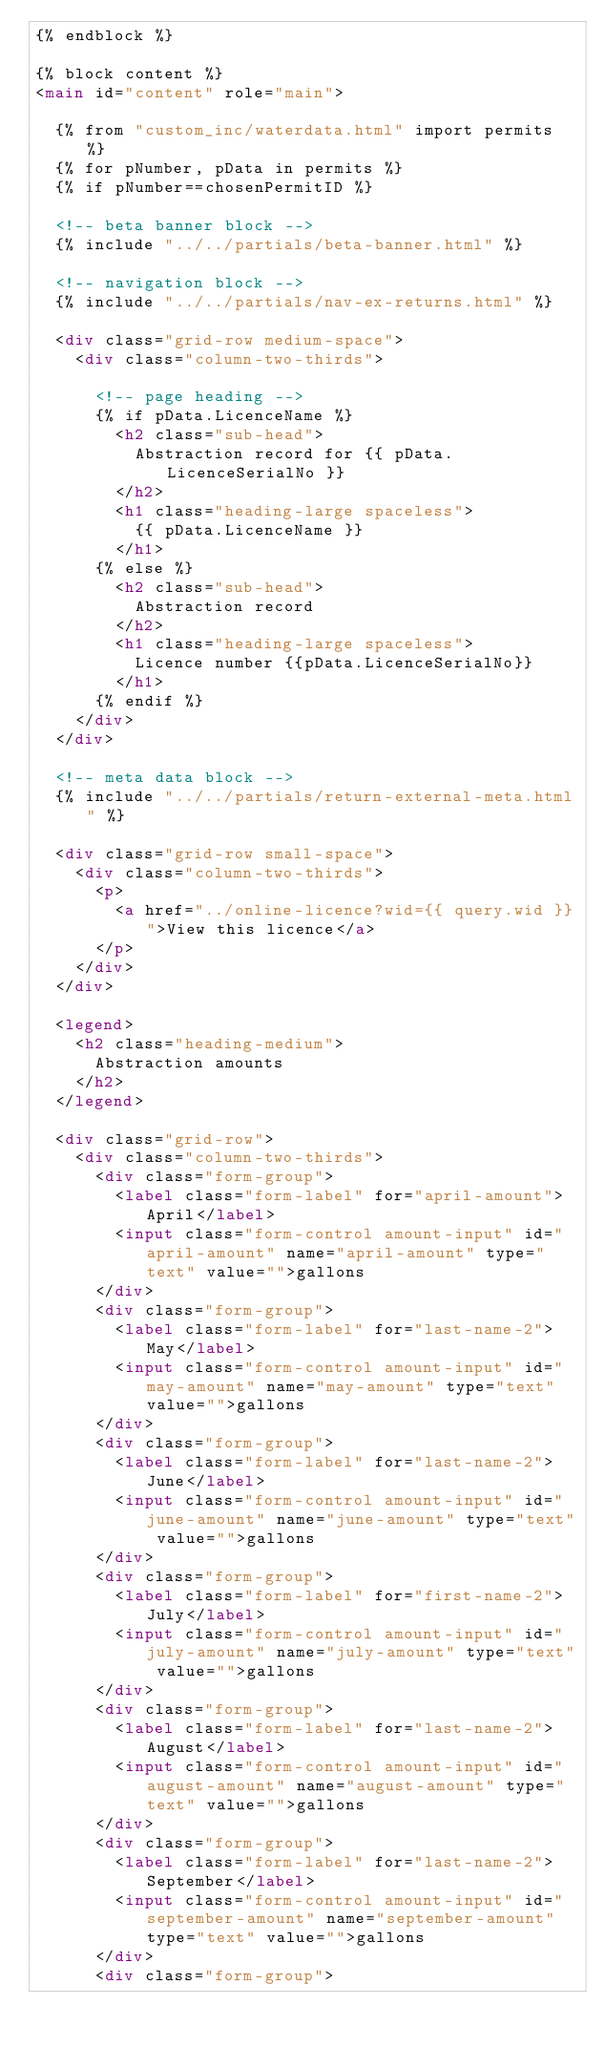Convert code to text. <code><loc_0><loc_0><loc_500><loc_500><_HTML_>{% endblock %}

{% block content %}
<main id="content" role="main">

  {% from "custom_inc/waterdata.html" import permits %}
  {% for pNumber, pData in permits %}
  {% if pNumber==chosenPermitID %}

  <!-- beta banner block -->
  {% include "../../partials/beta-banner.html" %}

  <!-- navigation block -->
  {% include "../../partials/nav-ex-returns.html" %}

  <div class="grid-row medium-space">
    <div class="column-two-thirds">

      <!-- page heading -->
      {% if pData.LicenceName %}
        <h2 class="sub-head">
          Abstraction record for {{ pData.LicenceSerialNo }}
        </h2>
        <h1 class="heading-large spaceless">
          {{ pData.LicenceName }}
        </h1>
      {% else %}
        <h2 class="sub-head">
          Abstraction record
        </h2>
        <h1 class="heading-large spaceless">
          Licence number {{pData.LicenceSerialNo}}
        </h1>
      {% endif %}
    </div>
  </div>

  <!-- meta data block -->
  {% include "../../partials/return-external-meta.html" %}

  <div class="grid-row small-space">
    <div class="column-two-thirds">
      <p>
        <a href="../online-licence?wid={{ query.wid }}">View this licence</a>
      </p>
    </div>
  </div>

  <legend>
    <h2 class="heading-medium">
      Abstraction amounts
    </h2>
  </legend>

  <div class="grid-row">
    <div class="column-two-thirds">
      <div class="form-group">
        <label class="form-label" for="april-amount">April</label>
        <input class="form-control amount-input" id="april-amount" name="april-amount" type="text" value="">gallons
      </div>
      <div class="form-group">
        <label class="form-label" for="last-name-2">May</label>
        <input class="form-control amount-input" id="may-amount" name="may-amount" type="text" value="">gallons
      </div>
      <div class="form-group">
        <label class="form-label" for="last-name-2">June</label>
        <input class="form-control amount-input" id="june-amount" name="june-amount" type="text" value="">gallons
      </div>
      <div class="form-group">
        <label class="form-label" for="first-name-2">July</label>
        <input class="form-control amount-input" id="july-amount" name="july-amount" type="text" value="">gallons
      </div>
      <div class="form-group">
        <label class="form-label" for="last-name-2">August</label>
        <input class="form-control amount-input" id="august-amount" name="august-amount" type="text" value="">gallons
      </div>
      <div class="form-group">
        <label class="form-label" for="last-name-2">September</label>
        <input class="form-control amount-input" id="september-amount" name="september-amount" type="text" value="">gallons
      </div>
      <div class="form-group"></code> 